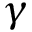Convert formula to latex. <formula><loc_0><loc_0><loc_500><loc_500>\gamma</formula> 